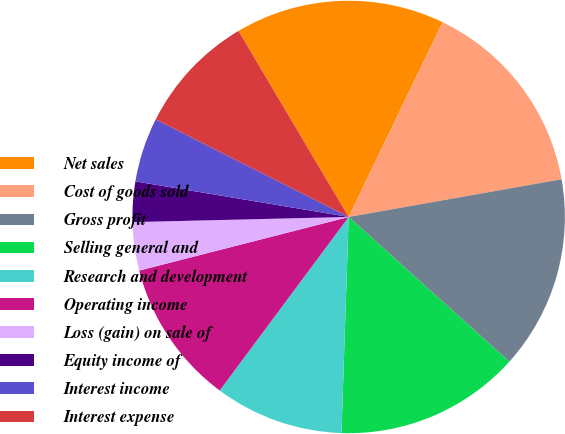Convert chart. <chart><loc_0><loc_0><loc_500><loc_500><pie_chart><fcel>Net sales<fcel>Cost of goods sold<fcel>Gross profit<fcel>Selling general and<fcel>Research and development<fcel>Operating income<fcel>Loss (gain) on sale of<fcel>Equity income of<fcel>Interest income<fcel>Interest expense<nl><fcel>15.66%<fcel>15.06%<fcel>14.46%<fcel>13.86%<fcel>9.64%<fcel>10.84%<fcel>3.61%<fcel>3.01%<fcel>4.82%<fcel>9.04%<nl></chart> 